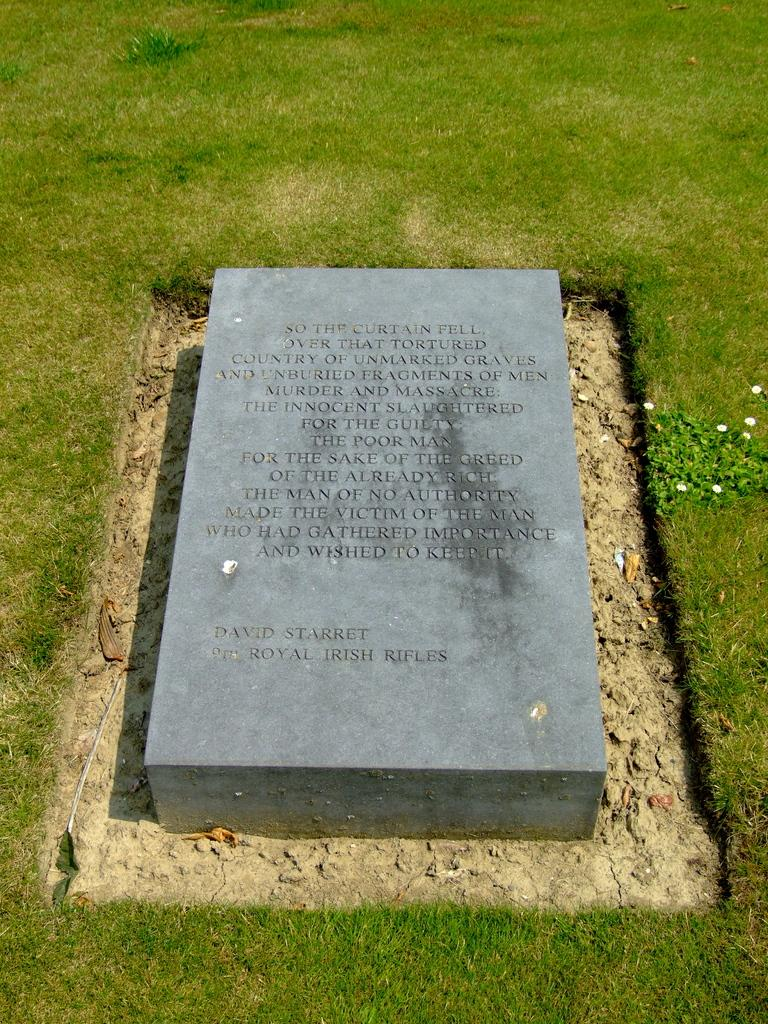What can be seen in the image? There is a grave in the image. What is written on the grave? There is text written on the grave. What is the landscape like around the grave? The land surrounding the grave is grassy. How many sisters does the passenger in the image have? There is no passenger or mention of any sisters in the image; it only features a grave with text on it. 